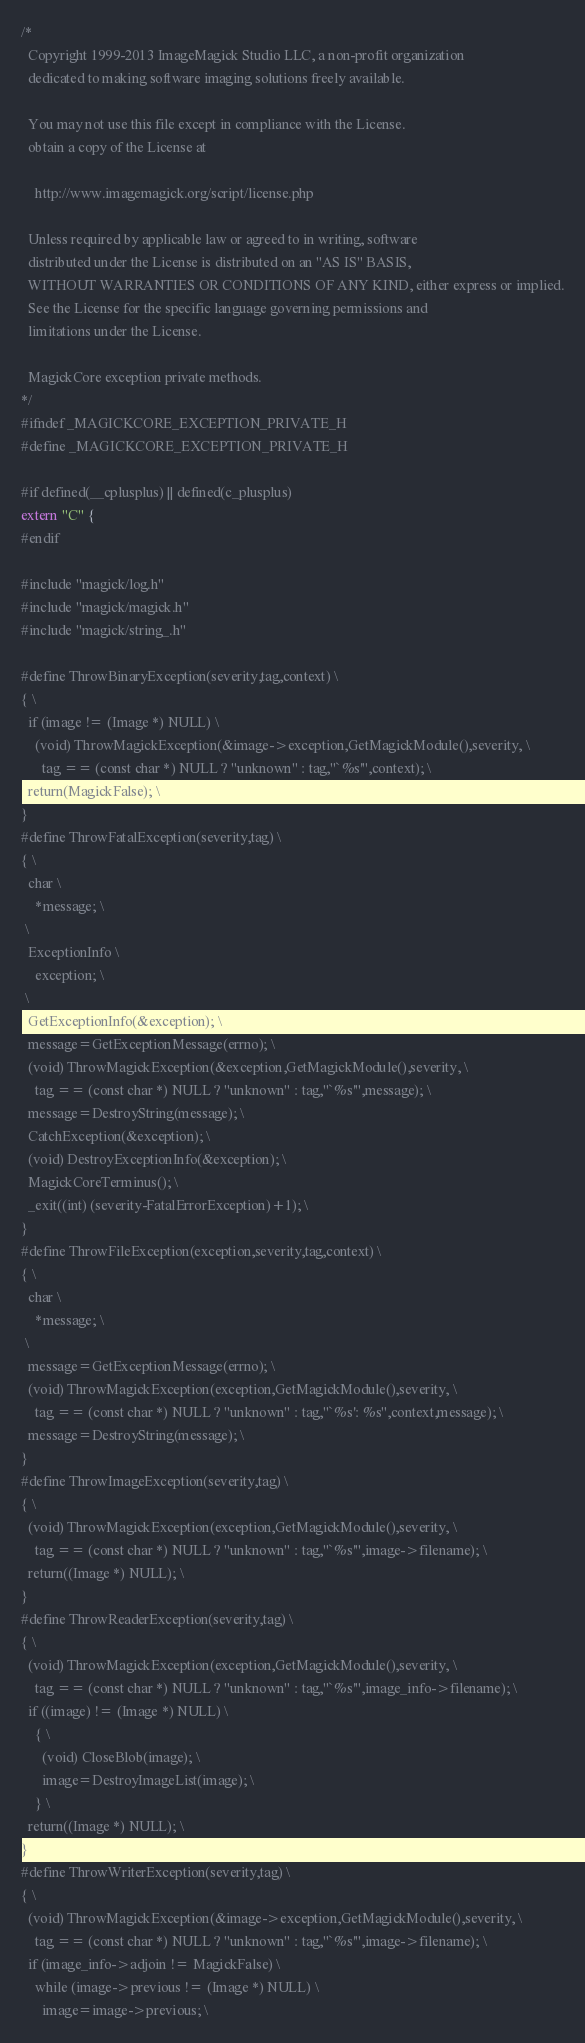Convert code to text. <code><loc_0><loc_0><loc_500><loc_500><_C_>/*
  Copyright 1999-2013 ImageMagick Studio LLC, a non-profit organization
  dedicated to making software imaging solutions freely available.
  
  You may not use this file except in compliance with the License.
  obtain a copy of the License at
  
    http://www.imagemagick.org/script/license.php
  
  Unless required by applicable law or agreed to in writing, software
  distributed under the License is distributed on an "AS IS" BASIS,
  WITHOUT WARRANTIES OR CONDITIONS OF ANY KIND, either express or implied.
  See the License for the specific language governing permissions and
  limitations under the License.

  MagickCore exception private methods.
*/
#ifndef _MAGICKCORE_EXCEPTION_PRIVATE_H
#define _MAGICKCORE_EXCEPTION_PRIVATE_H

#if defined(__cplusplus) || defined(c_plusplus)
extern "C" {
#endif

#include "magick/log.h"
#include "magick/magick.h"
#include "magick/string_.h"

#define ThrowBinaryException(severity,tag,context) \
{ \
  if (image != (Image *) NULL) \
    (void) ThrowMagickException(&image->exception,GetMagickModule(),severity, \
      tag == (const char *) NULL ? "unknown" : tag,"`%s'",context); \
  return(MagickFalse); \
}
#define ThrowFatalException(severity,tag) \
{ \
  char \
    *message; \
 \
  ExceptionInfo \
    exception; \
 \
  GetExceptionInfo(&exception); \
  message=GetExceptionMessage(errno); \
  (void) ThrowMagickException(&exception,GetMagickModule(),severity, \
    tag == (const char *) NULL ? "unknown" : tag,"`%s'",message); \
  message=DestroyString(message); \
  CatchException(&exception); \
  (void) DestroyExceptionInfo(&exception); \
  MagickCoreTerminus(); \
  _exit((int) (severity-FatalErrorException)+1); \
}
#define ThrowFileException(exception,severity,tag,context) \
{ \
  char \
    *message; \
 \
  message=GetExceptionMessage(errno); \
  (void) ThrowMagickException(exception,GetMagickModule(),severity, \
    tag == (const char *) NULL ? "unknown" : tag,"`%s': %s",context,message); \
  message=DestroyString(message); \
}
#define ThrowImageException(severity,tag) \
{ \
  (void) ThrowMagickException(exception,GetMagickModule(),severity, \
    tag == (const char *) NULL ? "unknown" : tag,"`%s'",image->filename); \
  return((Image *) NULL); \
}
#define ThrowReaderException(severity,tag) \
{ \
  (void) ThrowMagickException(exception,GetMagickModule(),severity, \
    tag == (const char *) NULL ? "unknown" : tag,"`%s'",image_info->filename); \
  if ((image) != (Image *) NULL) \
    { \
      (void) CloseBlob(image); \
      image=DestroyImageList(image); \
    } \
  return((Image *) NULL); \
}
#define ThrowWriterException(severity,tag) \
{ \
  (void) ThrowMagickException(&image->exception,GetMagickModule(),severity, \
    tag == (const char *) NULL ? "unknown" : tag,"`%s'",image->filename); \
  if (image_info->adjoin != MagickFalse) \
    while (image->previous != (Image *) NULL) \
      image=image->previous; \</code> 